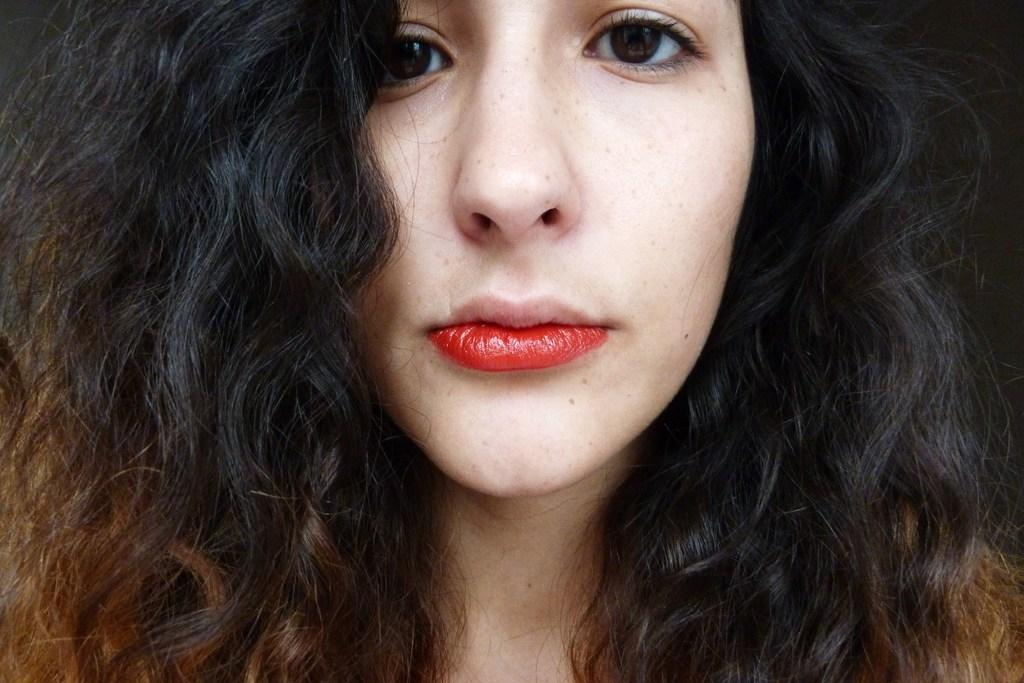Who is the main subject in the image? There is a woman in the image. What is the woman doing in the image? The woman is looking at the side. Can you describe the woman's appearance in the image? The woman is wearing red lipstick. What type of control does the woman have over the rain in the image? There is no rain present in the image, and therefore no control over it. 